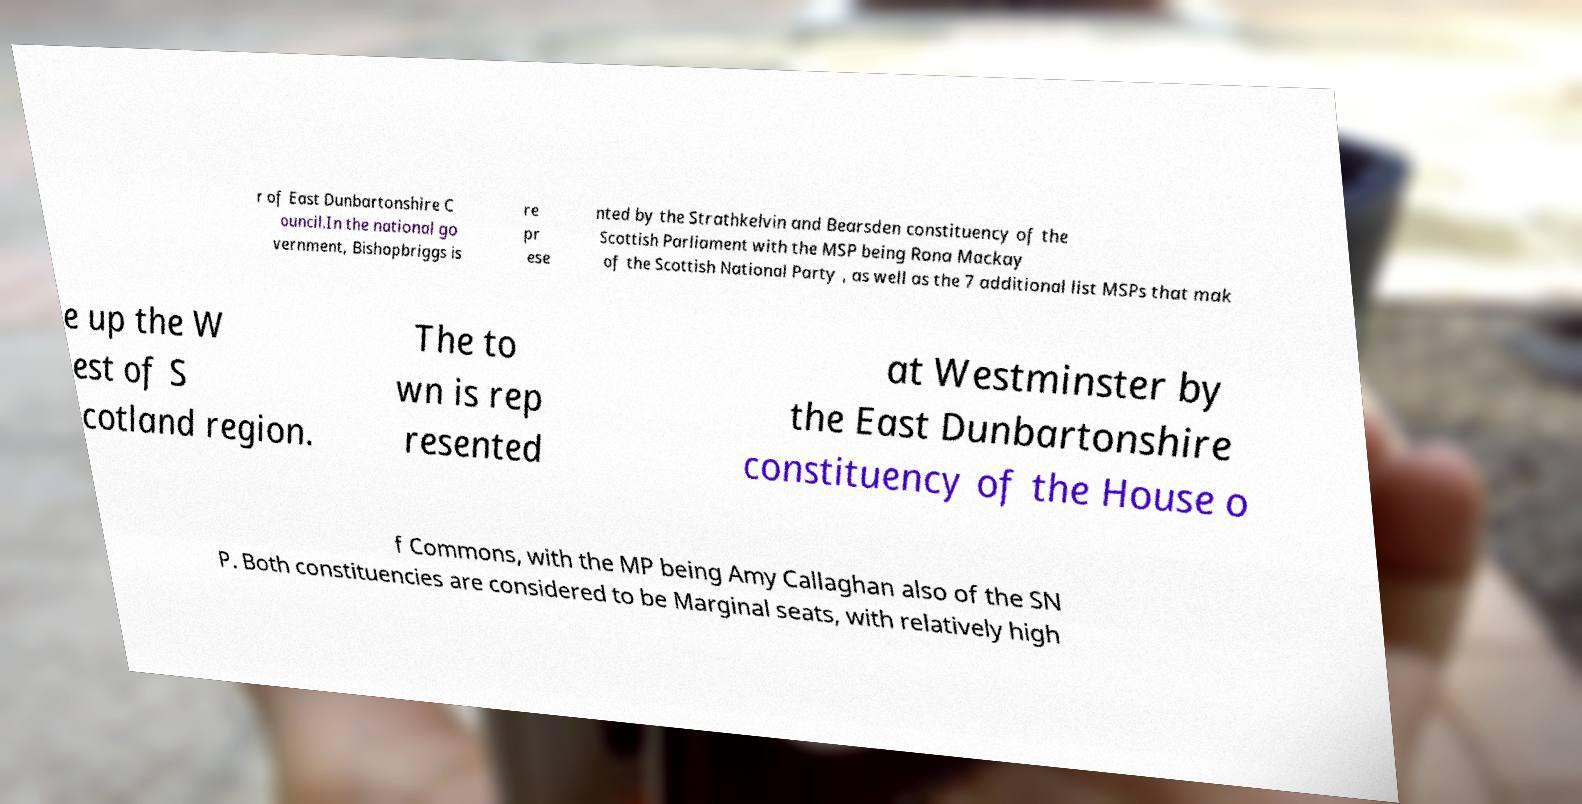Please identify and transcribe the text found in this image. r of East Dunbartonshire C ouncil.In the national go vernment, Bishopbriggs is re pr ese nted by the Strathkelvin and Bearsden constituency of the Scottish Parliament with the MSP being Rona Mackay of the Scottish National Party , as well as the 7 additional list MSPs that mak e up the W est of S cotland region. The to wn is rep resented at Westminster by the East Dunbartonshire constituency of the House o f Commons, with the MP being Amy Callaghan also of the SN P. Both constituencies are considered to be Marginal seats, with relatively high 